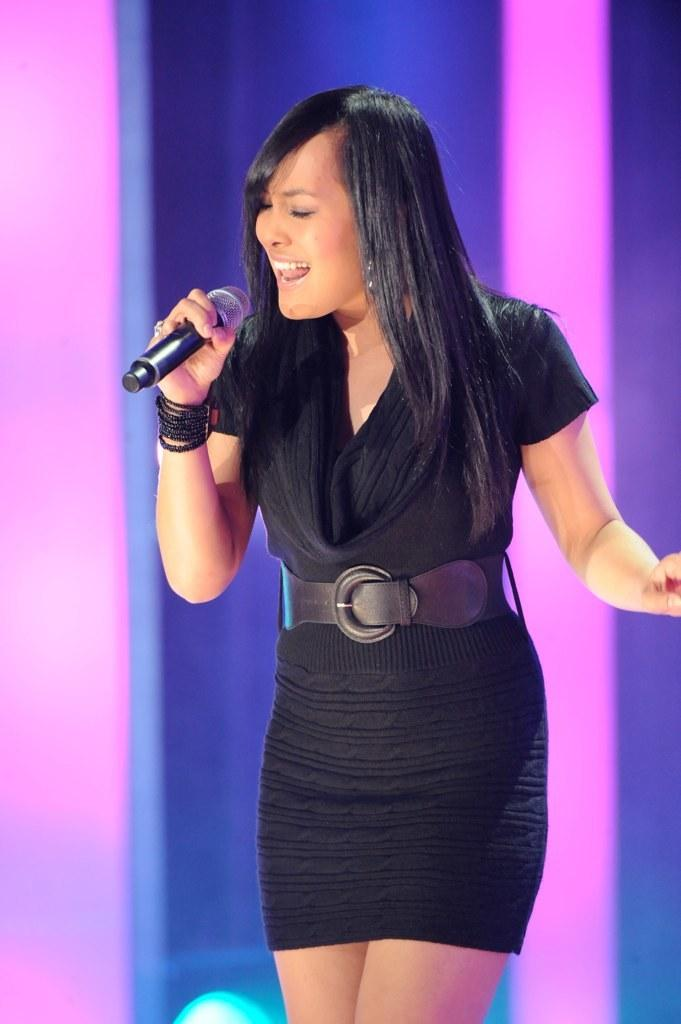Who is the main subject in the image? There is a woman in the image. What is the woman holding in the image? The woman is holding a mic. What is the woman doing in the image? The woman is singing. What is the woman wearing in the image? The woman is wearing a black dress. What colors can be seen in the background of the image? The background of the image has a blue and pink color. What type of lettuce can be seen in the woman's hair in the image? There is no lettuce present in the image, and the woman's hair does not have any lettuce in it. 